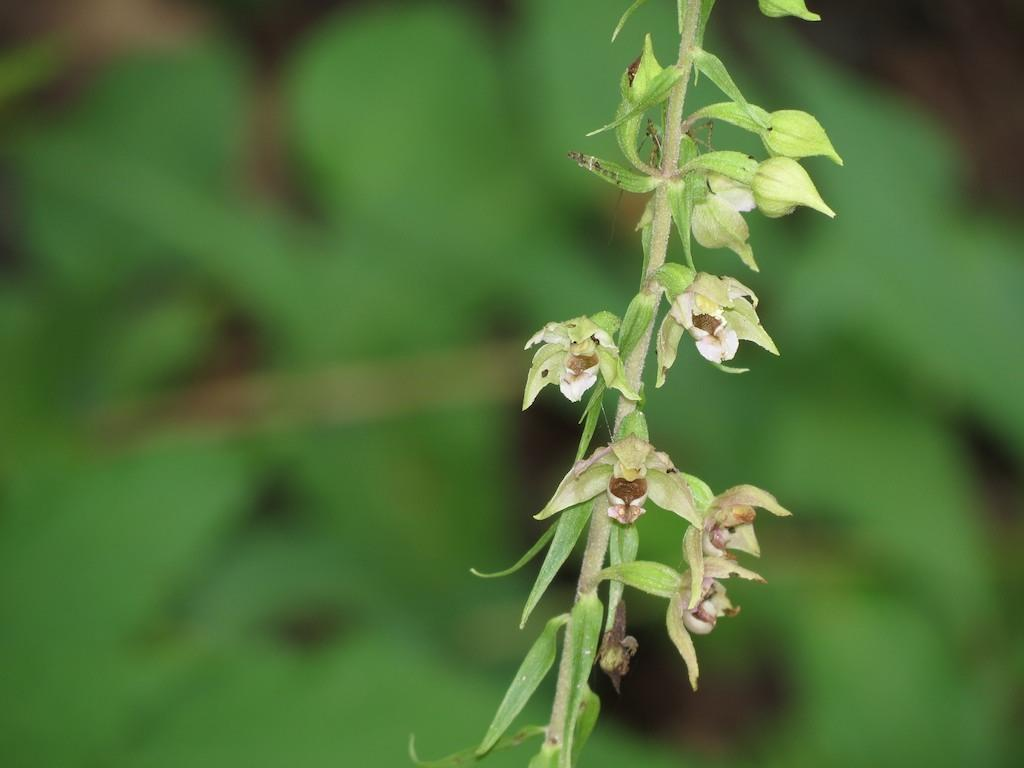What is located in the front of the image? There is a plant in the front of the image. What type of flora can be seen in the image? There are flowers in the image. Can you describe the background of the image? The background of the image is blurry. How does the snake move around in the image? There is no snake present in the image. What type of owl can be seen perched on the plant in the image? There is no owl present in the image; only a plant and flowers are visible. 